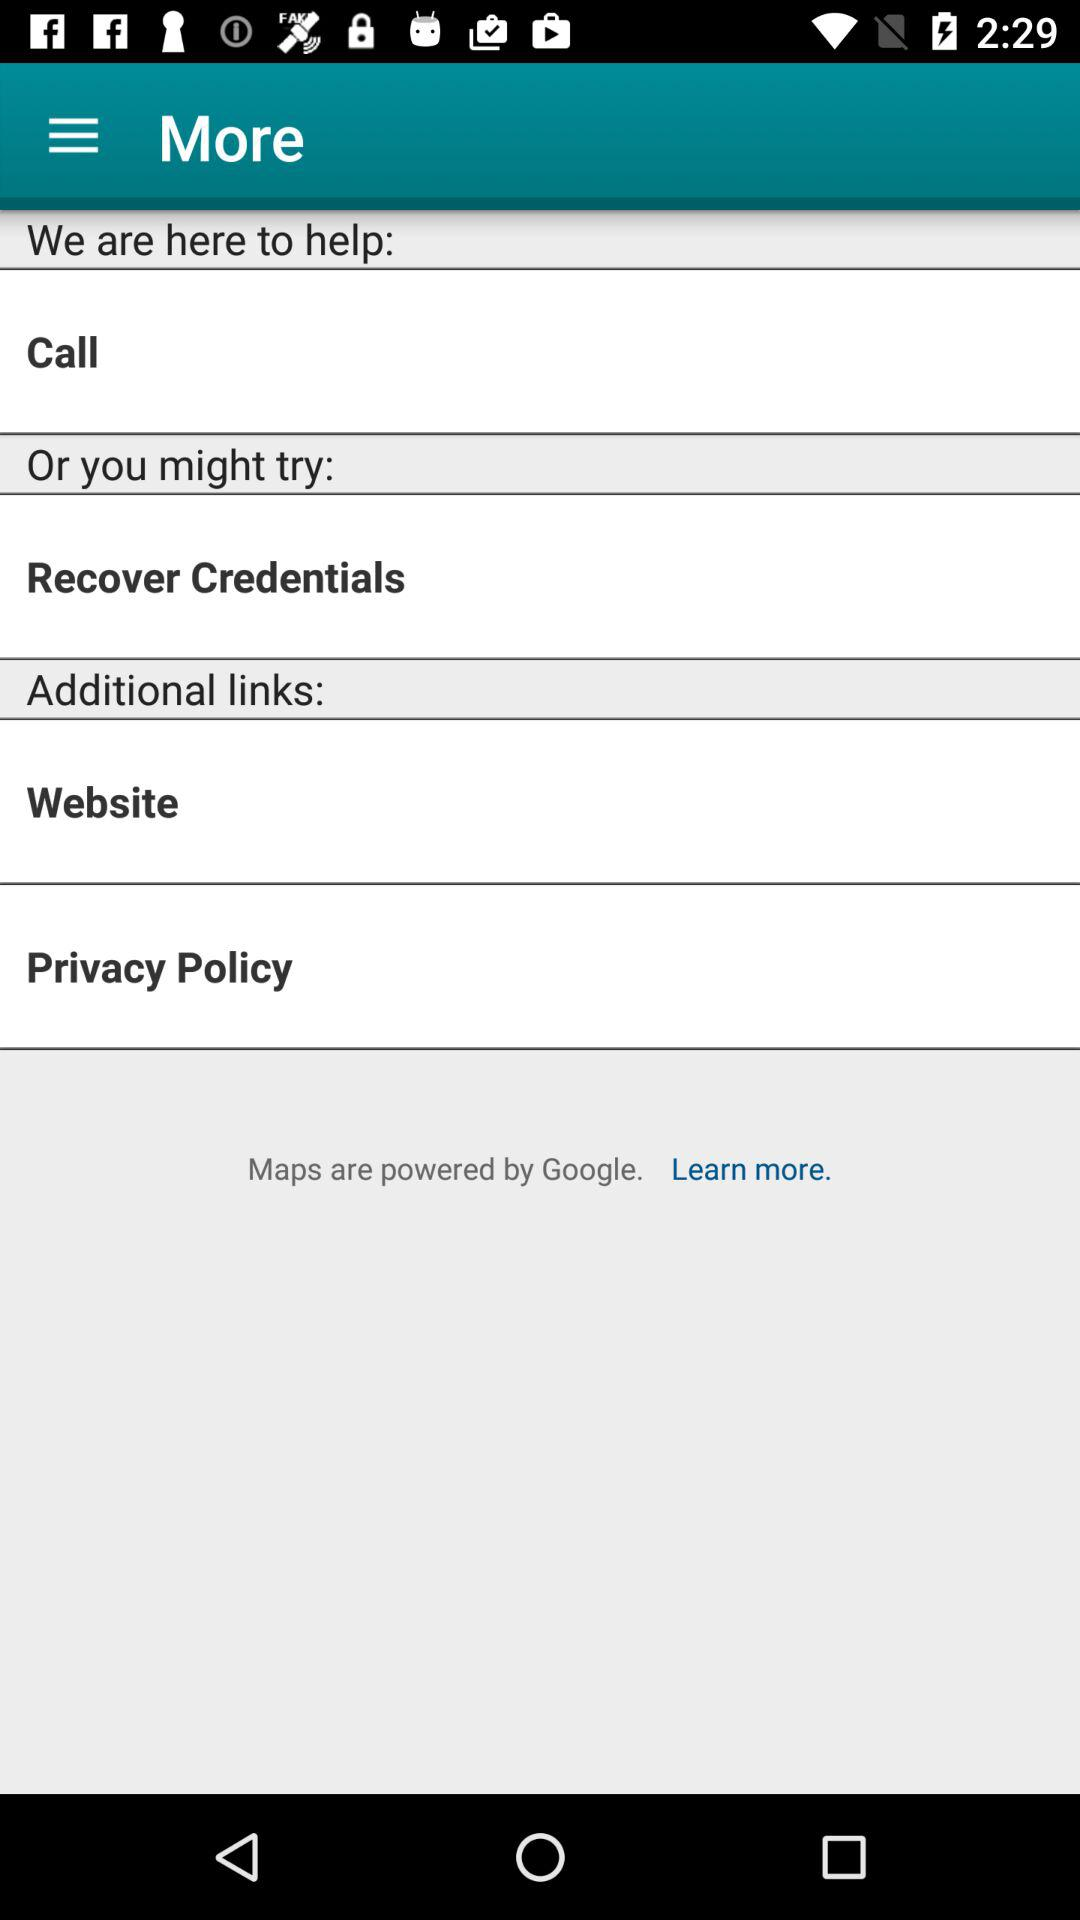By whom are maps powered? Maps are powered by Google. 